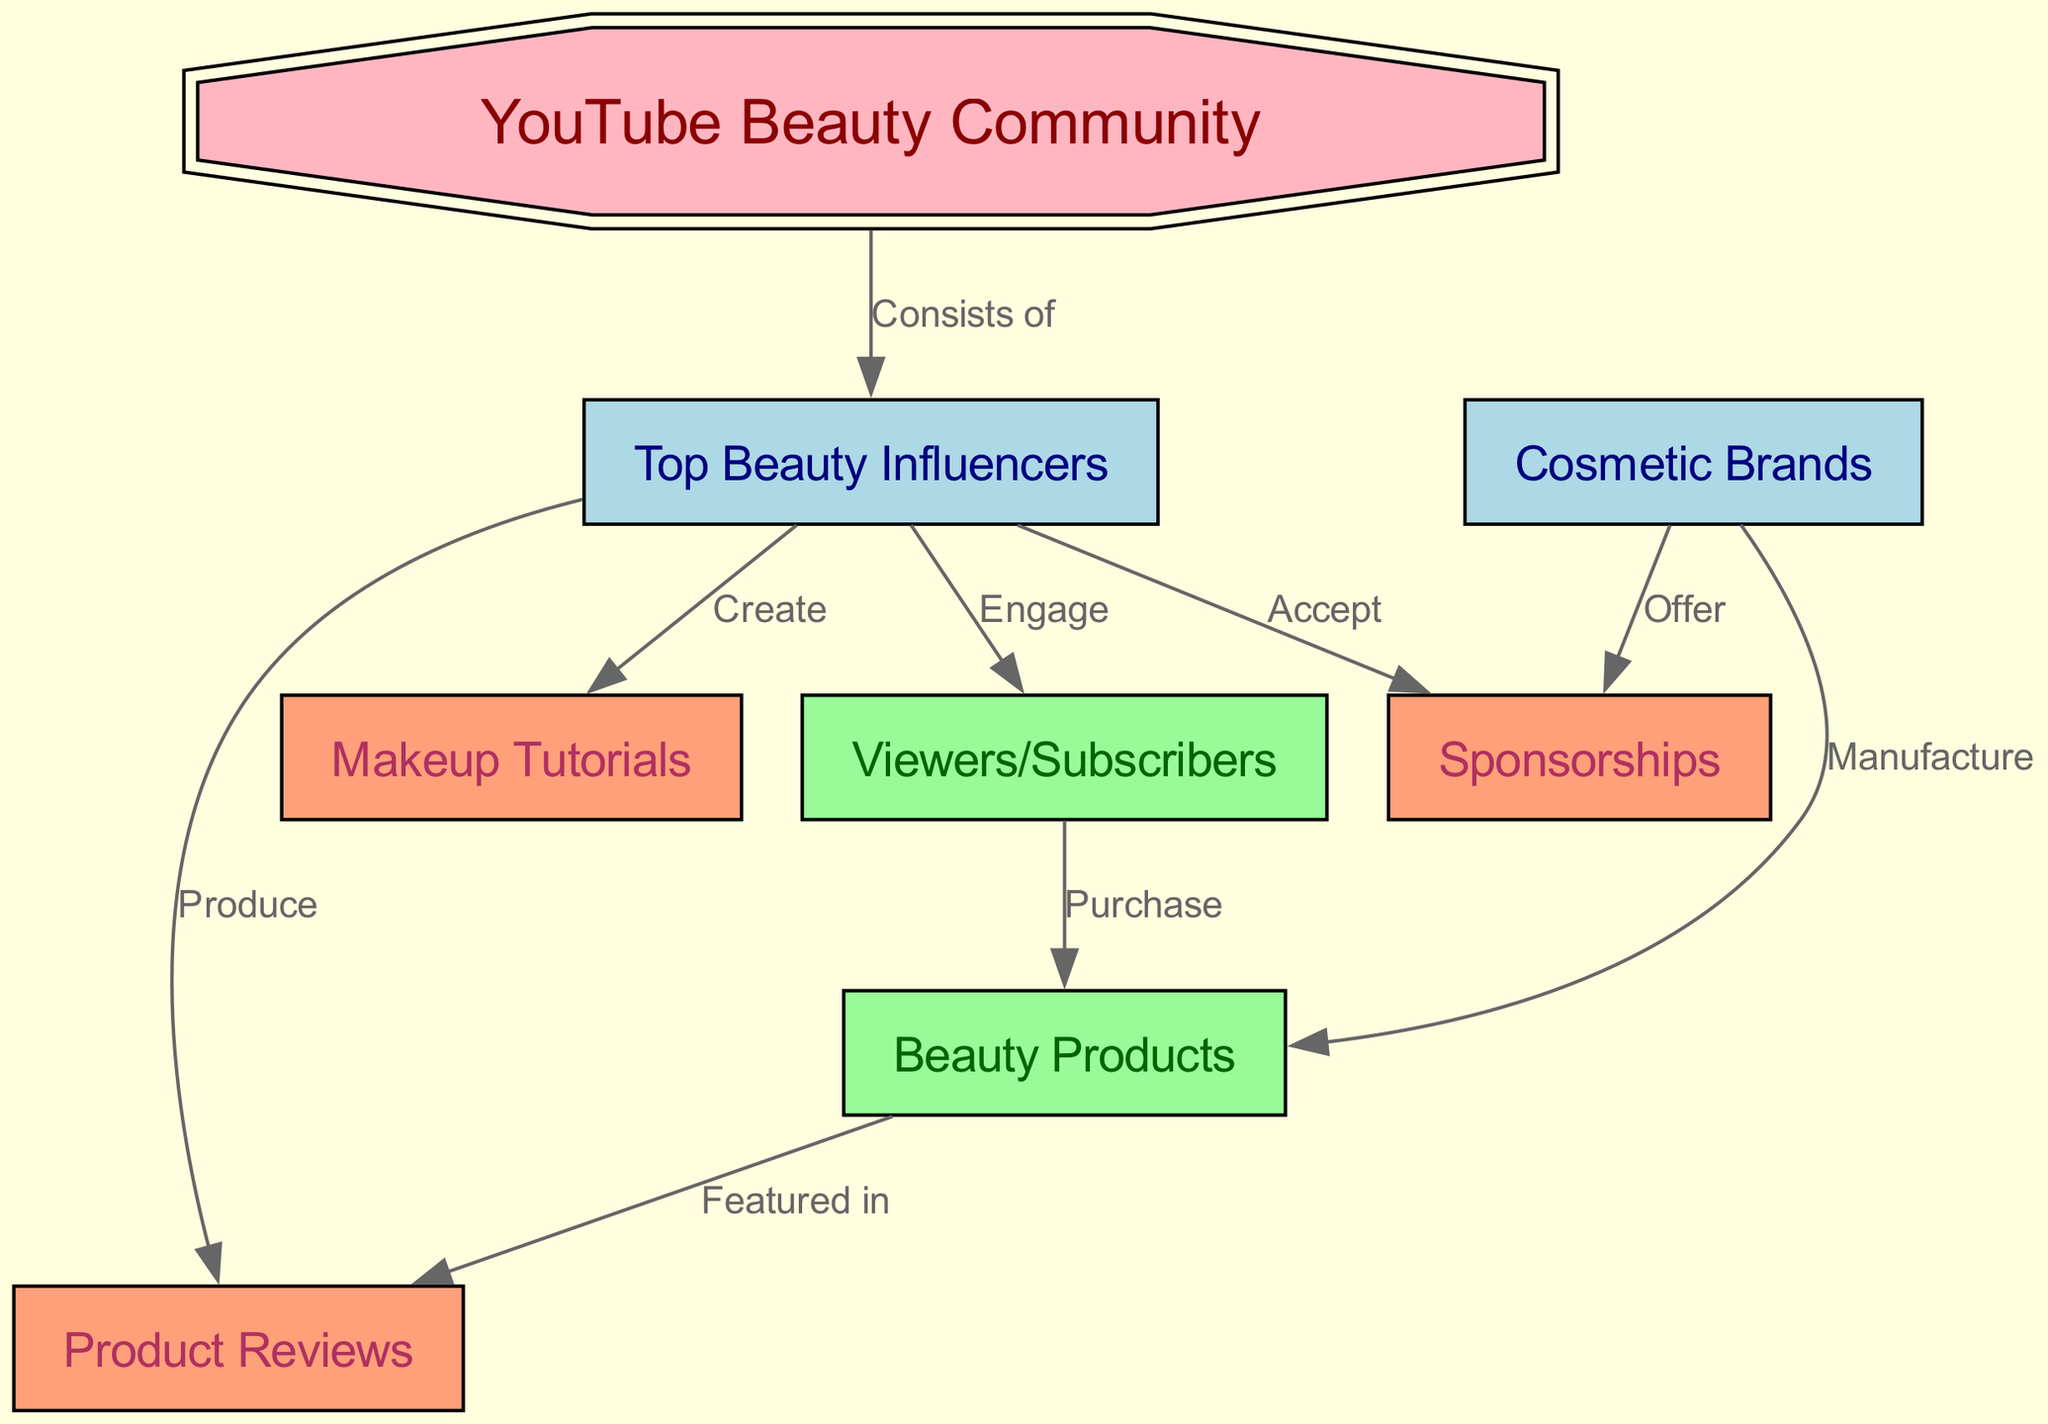What are the key players in the YouTube beauty community? The nodes in the diagram that represent key players include "Top Beauty Influencers," "Cosmetic Brands," and "Viewers/Subscribers." Each of these nodes signifies a distinct group that plays a crucial role in the ecosystem.
Answer: Top Beauty Influencers, Cosmetic Brands, Viewers/Subscribers How many nodes are in the diagram? By counting the individual nodes listed in the provided data, we see that there are eight nodes total: "YouTube Beauty Community," "Top Beauty Influencers," "Cosmetic Brands," "Viewers/Subscribers," "Beauty Products," "Makeup Tutorials," "Product Reviews," and "Sponsorships."
Answer: 8 What relationship do influencers have with viewers? The diagram indicates that "Top Beauty Influencers" engage with "Viewers/Subscribers." This connection highlights the interaction between these two groups within the community.
Answer: Engage Which entities manufacture beauty products? According to the diagram, "Cosmetic Brands" are responsible for manufacturing "Beauty Products." This relationship specifies the key players involved in product creation.
Answer: Cosmetic Brands What content do influencers create? The diagram demonstrates that influencers create "Makeup Tutorials." This means that beauty influencers produce tutorial content for their audience.
Answer: Makeup Tutorials What type of content are products featured in? The relationship shown in the diagram indicates that "Beauty Products" are featured in "Product Reviews." This connection illustrates how products are evaluated by influencers.
Answer: Product Reviews How do viewers interact with beauty products? Viewers/Subscribers purchase "Beauty Products," as indicated in the relationships outlined in the diagram. This interaction signifies the consumer behavior within the beauty community.
Answer: Purchase What do brands offer to influencers? The diagram clearly states that "Cosmetic Brands" offer "Sponsorships" to beauty influencers. This denotes a common relationship between brands and influencers in terms of collaboration initiatives.
Answer: Sponsorships What do influencers accept from brands? According to the diagram, "Top Beauty Influencers" accept "Sponsorships" from "Cosmetic Brands." This relationship emphasizes the mutual benefit in their interactions.
Answer: Sponsorships 